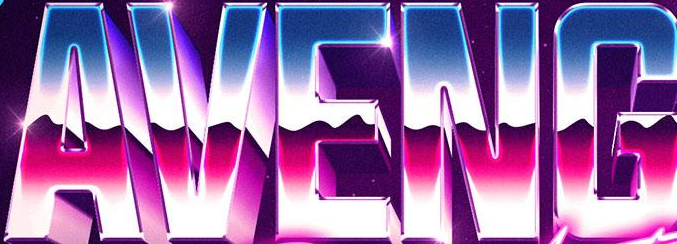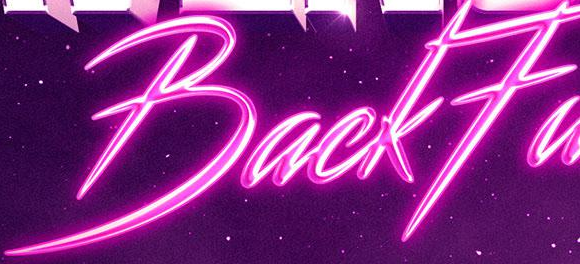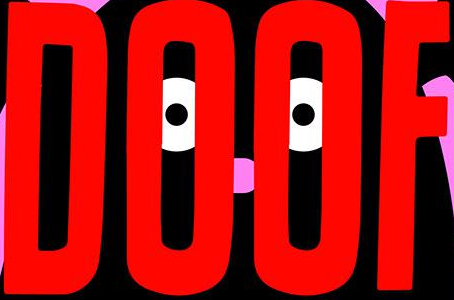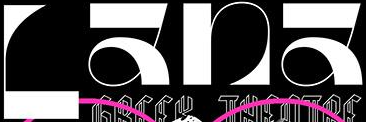What text is displayed in these images sequentially, separated by a semicolon? AVENG; BackFa; DOOF; Lana 